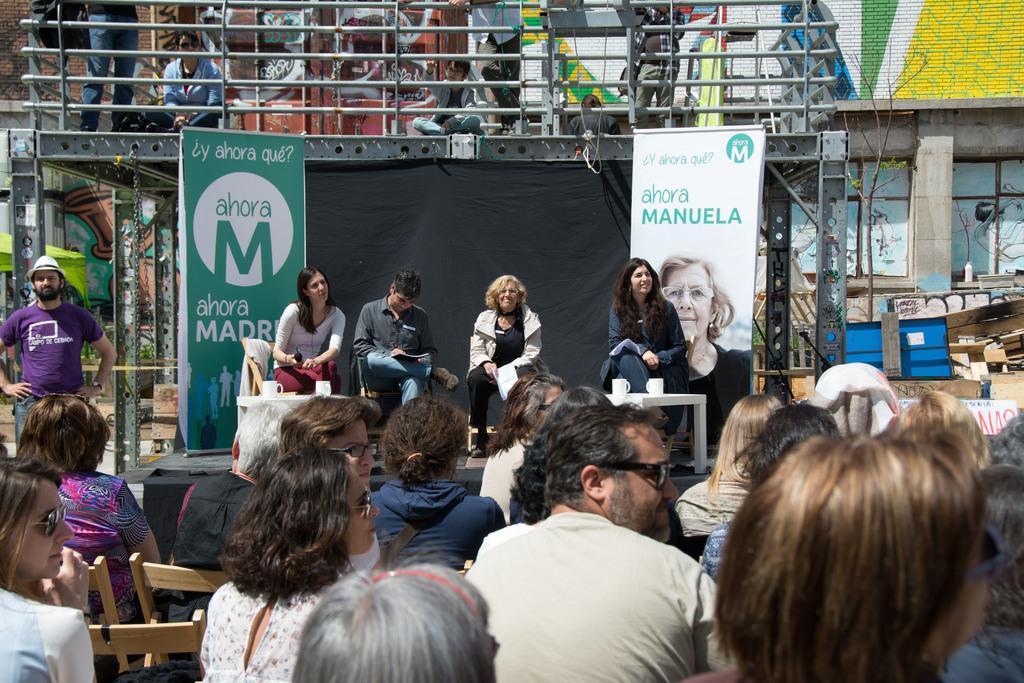Please provide a concise description of this image. In this image I can see group of people sitting. There are chairs, tables, white mugs, boards, and there is a black cloth. There is an iron platform which is supported with iron pillars and there is an iron fencing. In the background there are buildings and some other objects. 